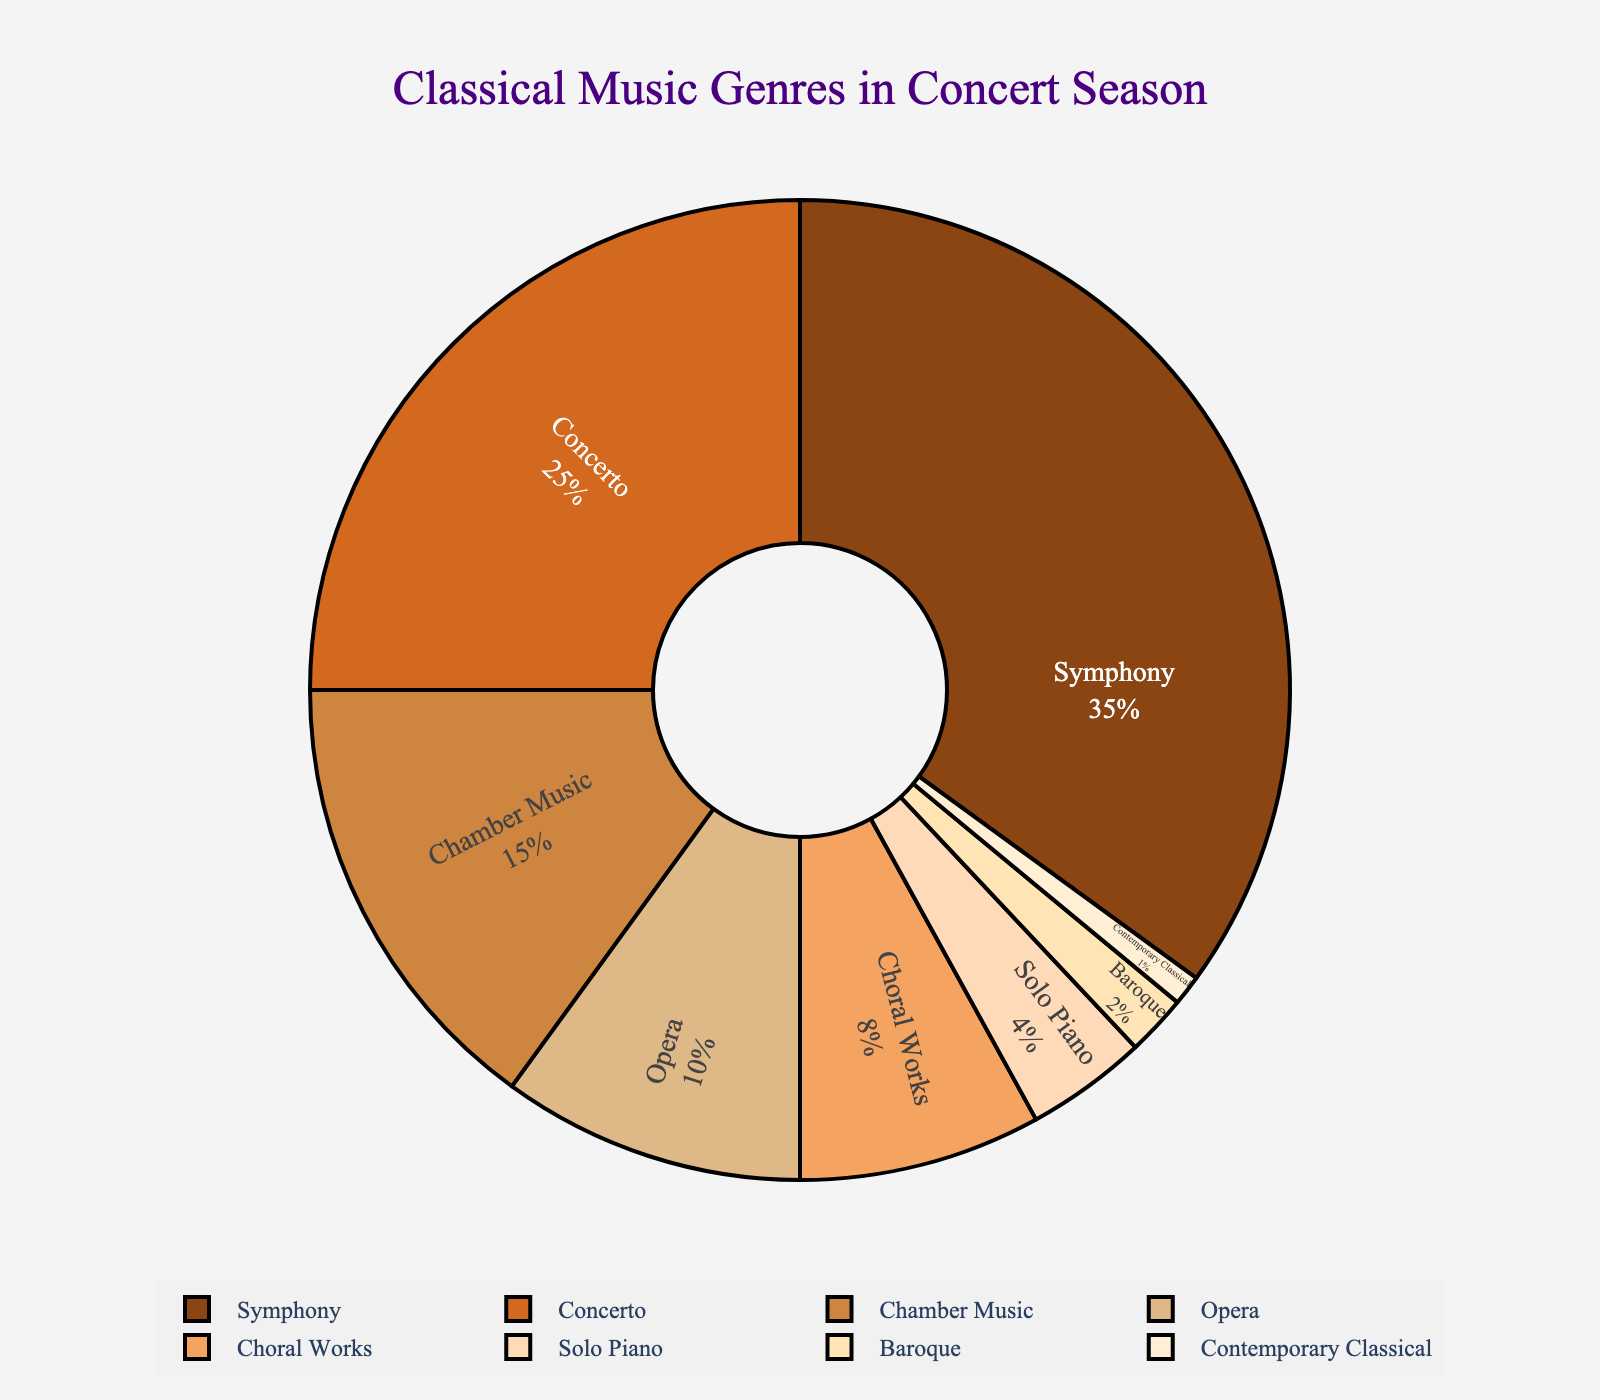What is the share of Symphony performances in the concert season? To find the share of Symphony performances, refer to the pie chart where Symphony is labeled, showing a 35% share.
Answer: 35% Which genre has the smallest representation in the concert season? To find the genre with the smallest representation, look for the smallest slice in the pie chart, which indicates Contemporary Classical at 1%.
Answer: Contemporary Classical How much larger is the share of Symphony performances compared to Chamber Music performances? Refer to the pie chart sections for Symphony and Chamber Music. Symphony is 35% and Chamber Music is 15%. The difference is 35% - 15% = 20%.
Answer: 20% What proportion of the concert season is dedicated to Concerto and Solo Piano combined? Add the percentages for Concerto (25%) and Solo Piano (4%). The combined total is 25% + 4% = 29%.
Answer: 29% Which two genres combined make up more than half of the concert season? Identify genres that, when summed, exceed 50%. Symphony (35%) and Concerto (25%) together total 35% + 25% = 60%, which is more than 50%.
Answer: Symphony and Concerto What is the visual difference in color between the genres Symphony and Opera? Identify the slices labeled Symphony and Opera. Symphony has a brownish color and Opera has a tan color.
Answer: Brownish vs. Tan Compare the shares of Choral Works and Chamber Music. Which genre has a higher share, and by how much? Look at the percentages for Choral Works (8%) and Chamber Music (15%). Chamber Music is higher. The difference is 15% - 8% = 7%.
Answer: Chamber Music by 7% If you combine Baroque and Contemporary Classical, how does their combined proportion compare to Choral Works? Add the proportions for Baroque (2%) and Contemporary Classical (1%), which equals 3%. Choral Works is 8%, so 3% is less than 8%.
Answer: Less than What is the percentage difference between the largest and smallest genre shares? The largest genre is Symphony at 35%, and the smallest is Contemporary Classical at 1%. The difference is 35% - 1% = 34%.
Answer: 34% Which genres make up less than 10% of the concert season each? Identify each genre's percentage. Baroque (2%), Contemporary Classical (1%), Solo Piano (4%), and Opera (10%) are all less than 10%.
Answer: Baroque, Contemporary Classical, Solo Piano 